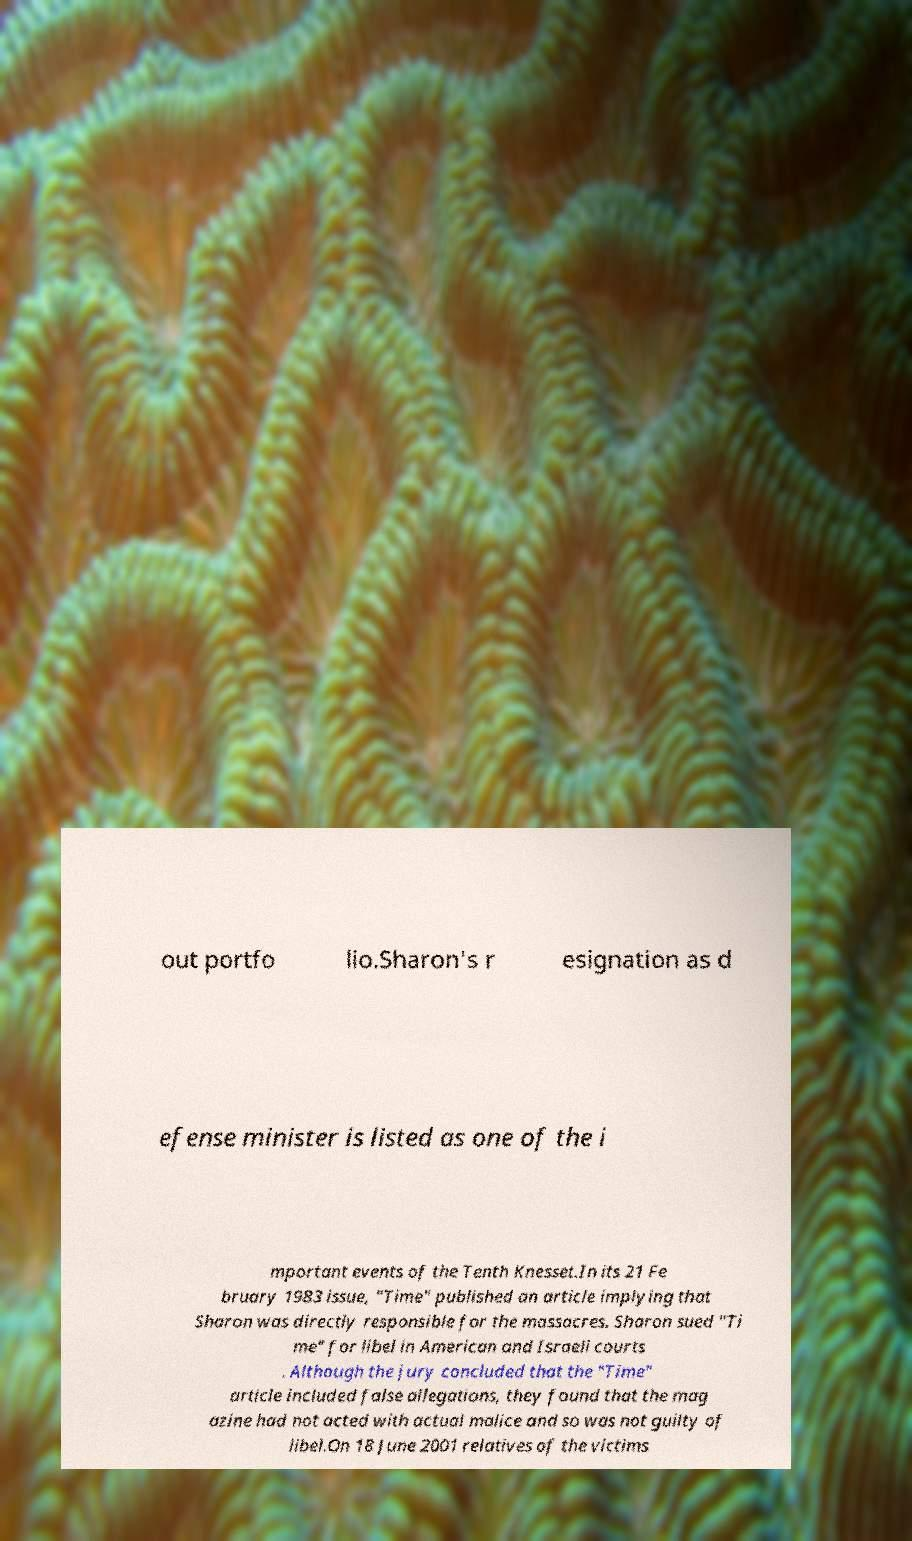Can you read and provide the text displayed in the image?This photo seems to have some interesting text. Can you extract and type it out for me? out portfo lio.Sharon's r esignation as d efense minister is listed as one of the i mportant events of the Tenth Knesset.In its 21 Fe bruary 1983 issue, "Time" published an article implying that Sharon was directly responsible for the massacres. Sharon sued "Ti me" for libel in American and Israeli courts . Although the jury concluded that the "Time" article included false allegations, they found that the mag azine had not acted with actual malice and so was not guilty of libel.On 18 June 2001 relatives of the victims 